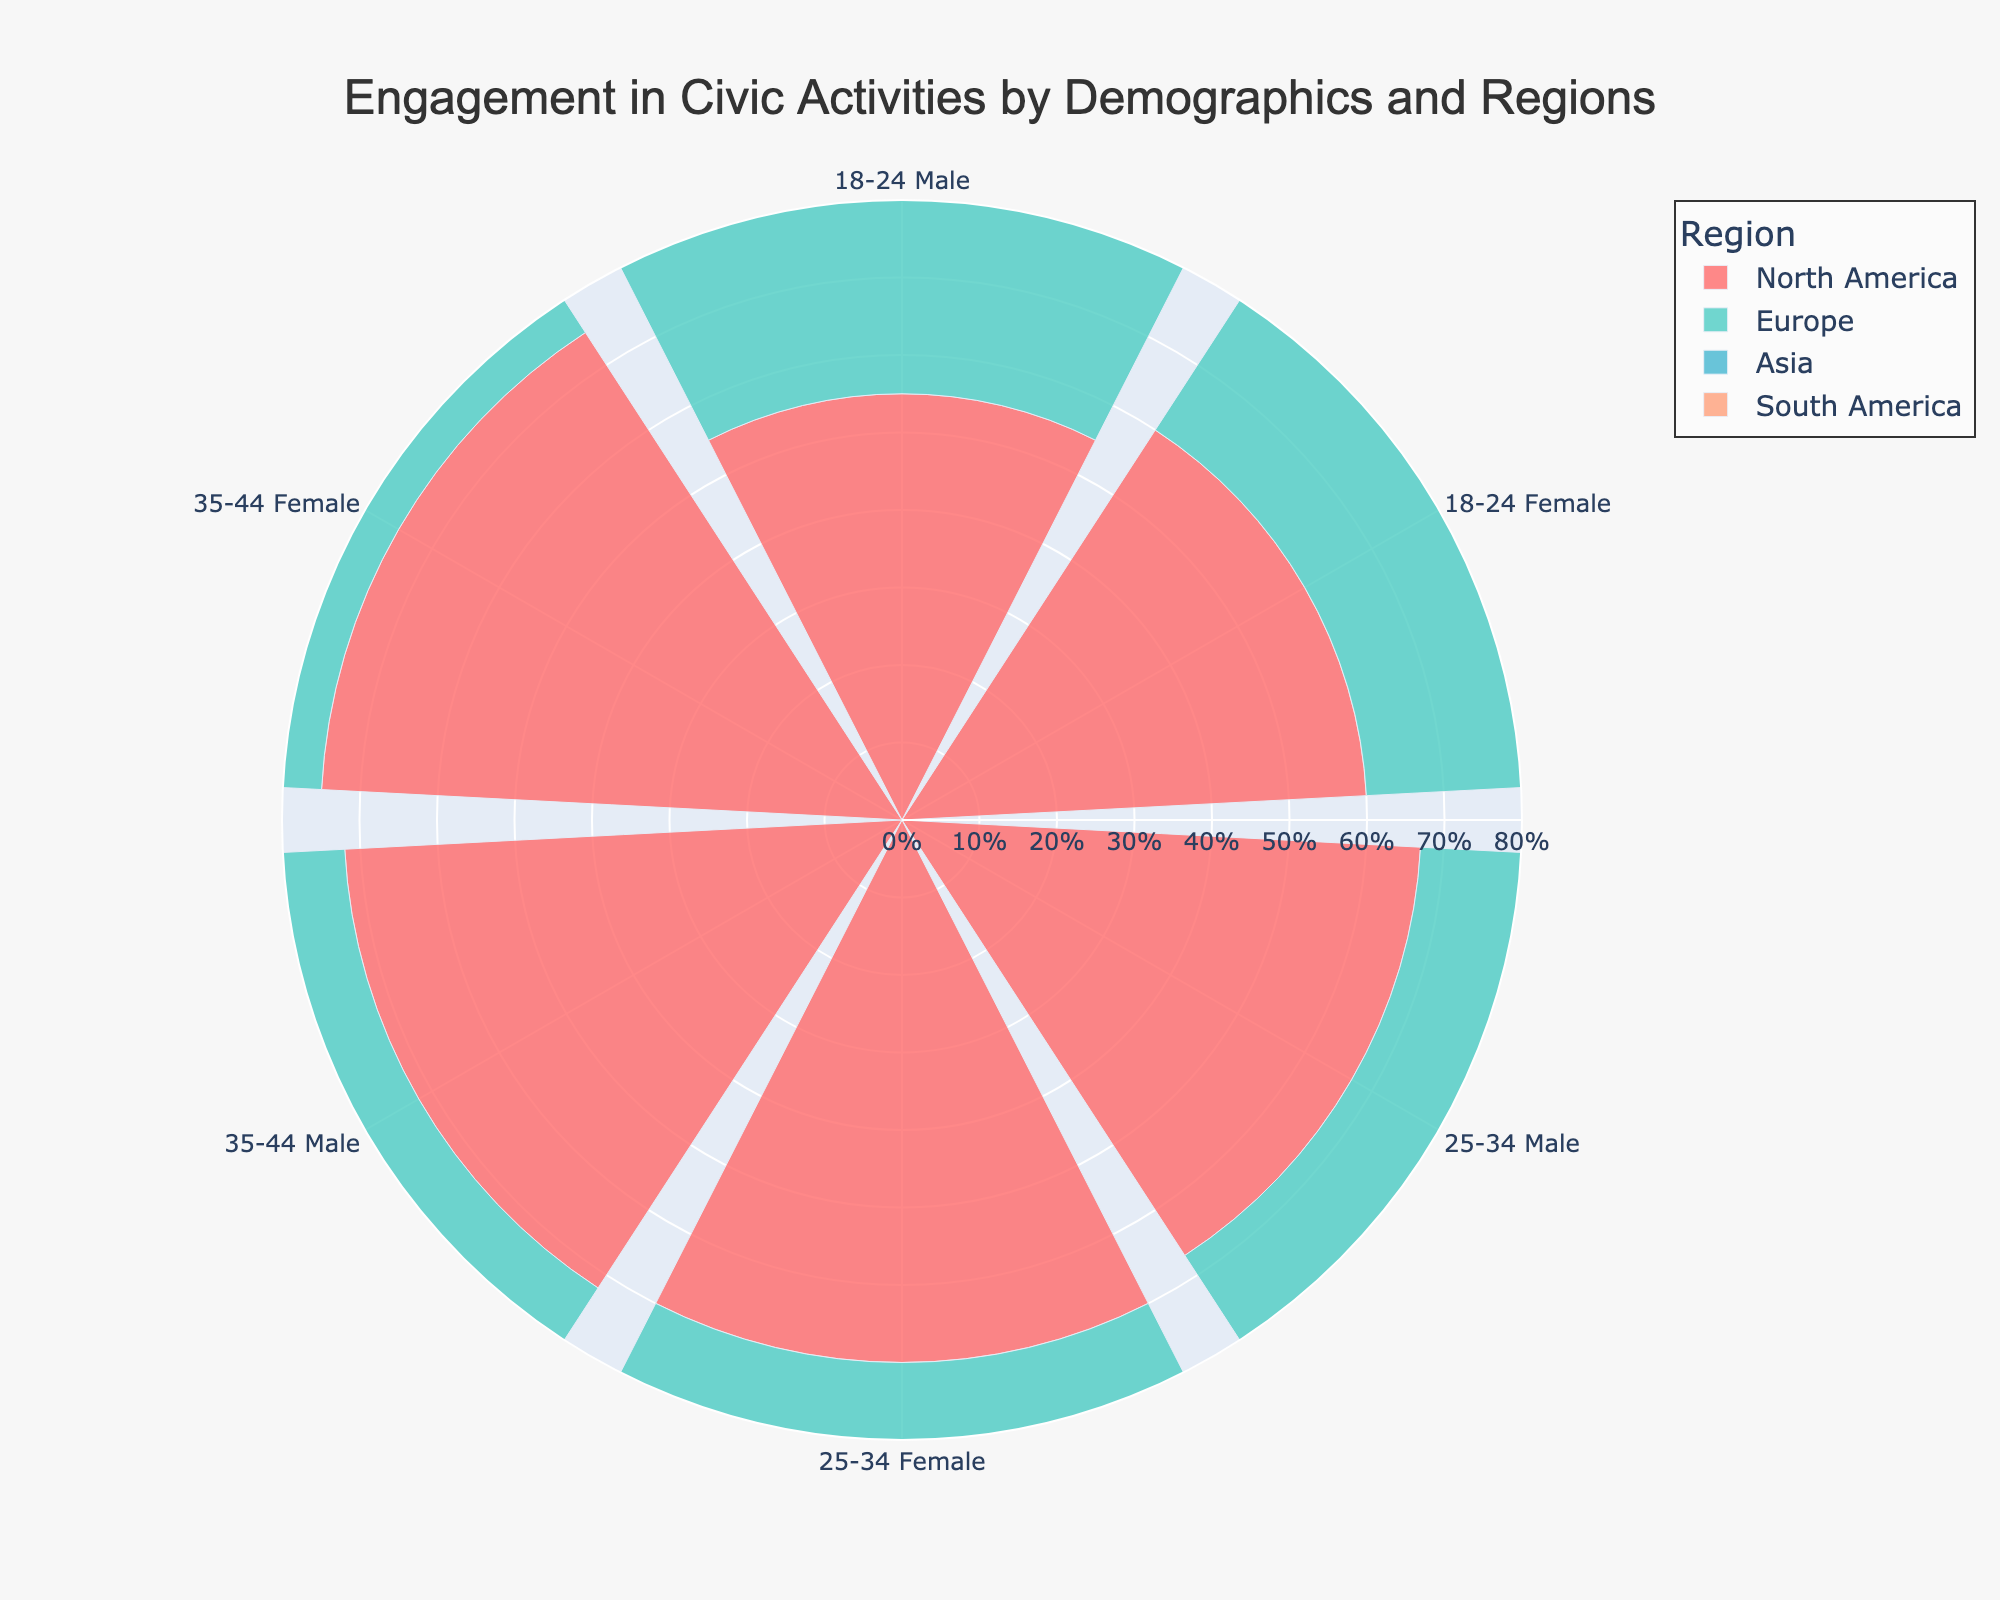What is the title of the figure? The title of the figure is displayed at the top and reads as follows: 'Engagement in Civic Activities by Demographics and Regions'.
Answer: Engagement in Civic Activities by Demographics and Regions How are the regions distinguished in the figure? Four distinct colors are used to represent the regions: North America, Europe, Asia, and South America. Each region has a unique color for the identification of their respective data segments.
Answer: By unique colors Which age group and gender in Europe have the highest participation in civic activities? To find this, we look at the segments for Europe and identify the highest radial value in the respective age groups and genders. The segment for females aged 35-44 has the highest participation.
Answer: Females aged 35-44 Compare the participation in civic activities for males aged 25-34 between North America and South America. To answer this, check the radial segments for males aged 25-34 in both regions. North America shows 67%, while South America shows 60%. North America has a higher participation.
Answer: North America What is the average participation rate for females in Asia across all age groups? To calculate the average participation rate for females in Asia, add the percentages for 18-24 (52%), 25-34 (66%), and 35-44 (73%), then divide by the number of age groups: (52 + 66 + 73) / 3.
Answer: 63.67% Which region shows the least difference in participation between males and females aged 18-24? Evaluate the difference between males and females aged 18-24 across all regions. North America has a difference of 5%, Europe 8%, Asia 7%, and South America 6%. North America has the least difference.
Answer: North America How does the participation of females with a Master's degree compare between Asia and Europe? By examining the radial segments for females with a Master's degree in Asia (73%) and Europe (74%), we see that Europe has a slightly higher participation rate.
Answer: Europe Based on the figure, what can be inferred about the trend of civic engagement with increasing education levels across all regions? Observing the figure, it is evident that participation in civic activities generally increases with higher education levels across all regions.
Answer: Participation increases What’s the difference in participation between males and females aged 35-44 in North America? Find the radial values for both males and females aged 35-44 in North America. For males, it is 72%, and for females, it is 75%. The difference is 3%.
Answer: 3% Which age group in North America shows the highest increase in participation from males to females? Assess the difference in participation rates between males and females for each age group. The 18-24 age group shows a difference from 55% (males) to 60% (females), or 5%. The 25-34 age group shows an increase from 67% (males) to 70% (females), or 3%. The 35-44 age group shows a difference from 72% (males) to 75% (females), or 3%. Therefore, the 18-24 age group shows the highest increase (5%).
Answer: 18-24 